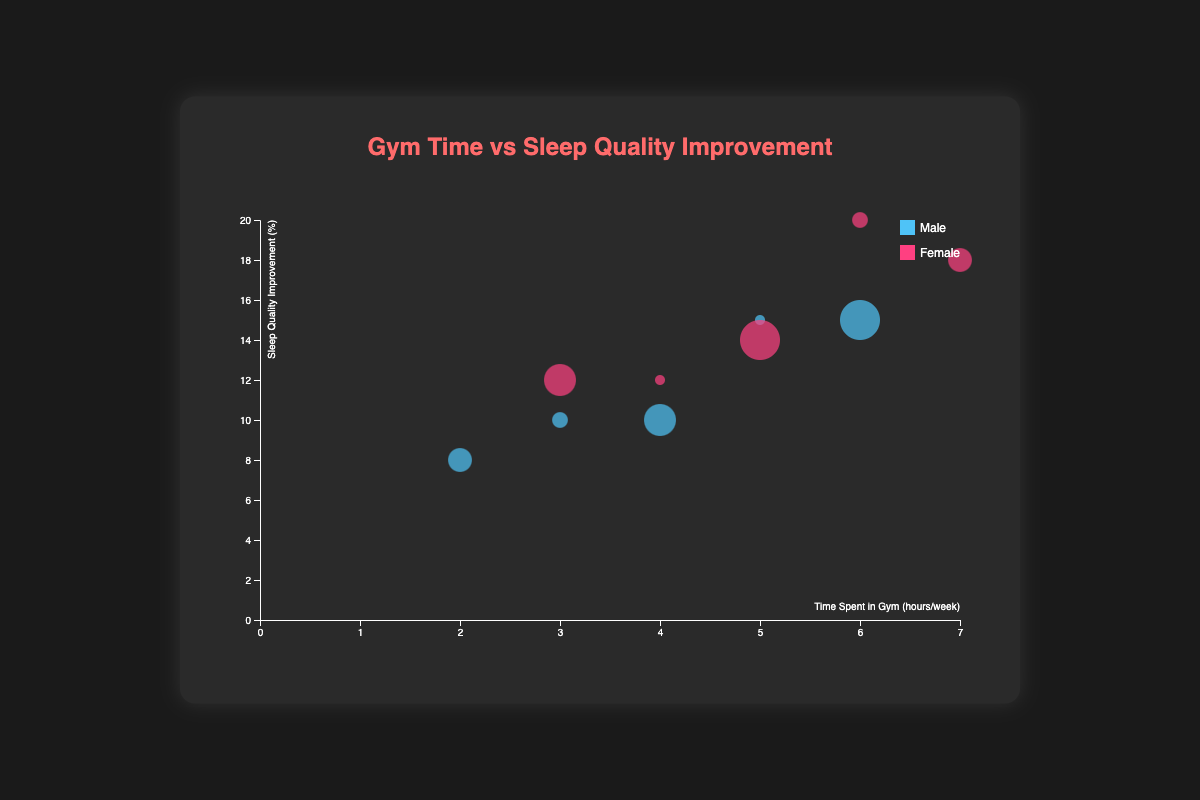What's the title of the chart? The title of the chart is prominently displayed at the top. It reads "Gym Time vs Sleep Quality Improvement."
Answer: Gym Time vs Sleep Quality Improvement Which gender is represented by the pink bubbles? The legend indicates that pink bubbles represent female members. This is clearly shown by the color coding in the legend next to the word "Female."
Answer: Female What is the range of the x-axis? The x-axis represents time spent in the gym and is labeled with values that go from 0 to 7 hours per week, as shown by the tick marks.
Answer: 0-7 hours per week How many female members aged 45-54 are represented in the chart? By observing the pink bubbles and looking at the tooltip information when hovering over the bubbles, there is one pink bubble representing a female aged 45-54.
Answer: 1 Which gender shows the highest sleep quality improvement, and what is the percentage? By looking at the highest bubble position on the y-axis and verifying the tooltip, the highest sleep quality improvement (20%) belongs to a female.
Answer: Female (20%) Compare the sleep quality improvement between males aged 18-24 and 55-64 who spent 5 hours in the gym. By examining bubbles for males aged 18-24 and 55-64, the sleep quality improvement is 15% for both age groups.
Answer: 15% for both Which age group has the largest bubble size and what does this indicate? The largest bubbles represent older age groups due to the size scaling with age; thus, the age group 55-64 has the largest bubbles.
Answer: 55-64 What is the total sleep quality improvement percentage for females of all age groups? Adding the sleep quality improvements for each female: 12% + 20% + 18% + 12% + 14% equals 76%.
Answer: 76% Which data point represents a member spending 4 hours in the gym and achieving 10% sleep improvement? What is the gender and age group? Hovering over the bubble positioned at (4, 10) hours, the tooltip reveals a male in the 45-54 age group.
Answer: Male, 45-54 Is there a clear trend showing increased gym time correlates with improved sleep quality across all age groups? Observing the scatter of bubbles, there's a general trend suggesting that more time spent in the gym leads to higher sleep quality improvement. This trend is more evident among certain age groups.
Answer: Yes, generally 